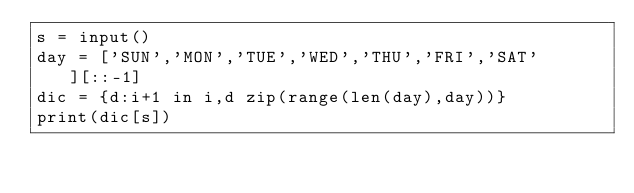Convert code to text. <code><loc_0><loc_0><loc_500><loc_500><_Python_>s = input() 
day = ['SUN','MON','TUE','WED','THU','FRI','SAT'][::-1]
dic = {d:i+1 in i,d zip(range(len(day),day))}
print(dic[s])</code> 